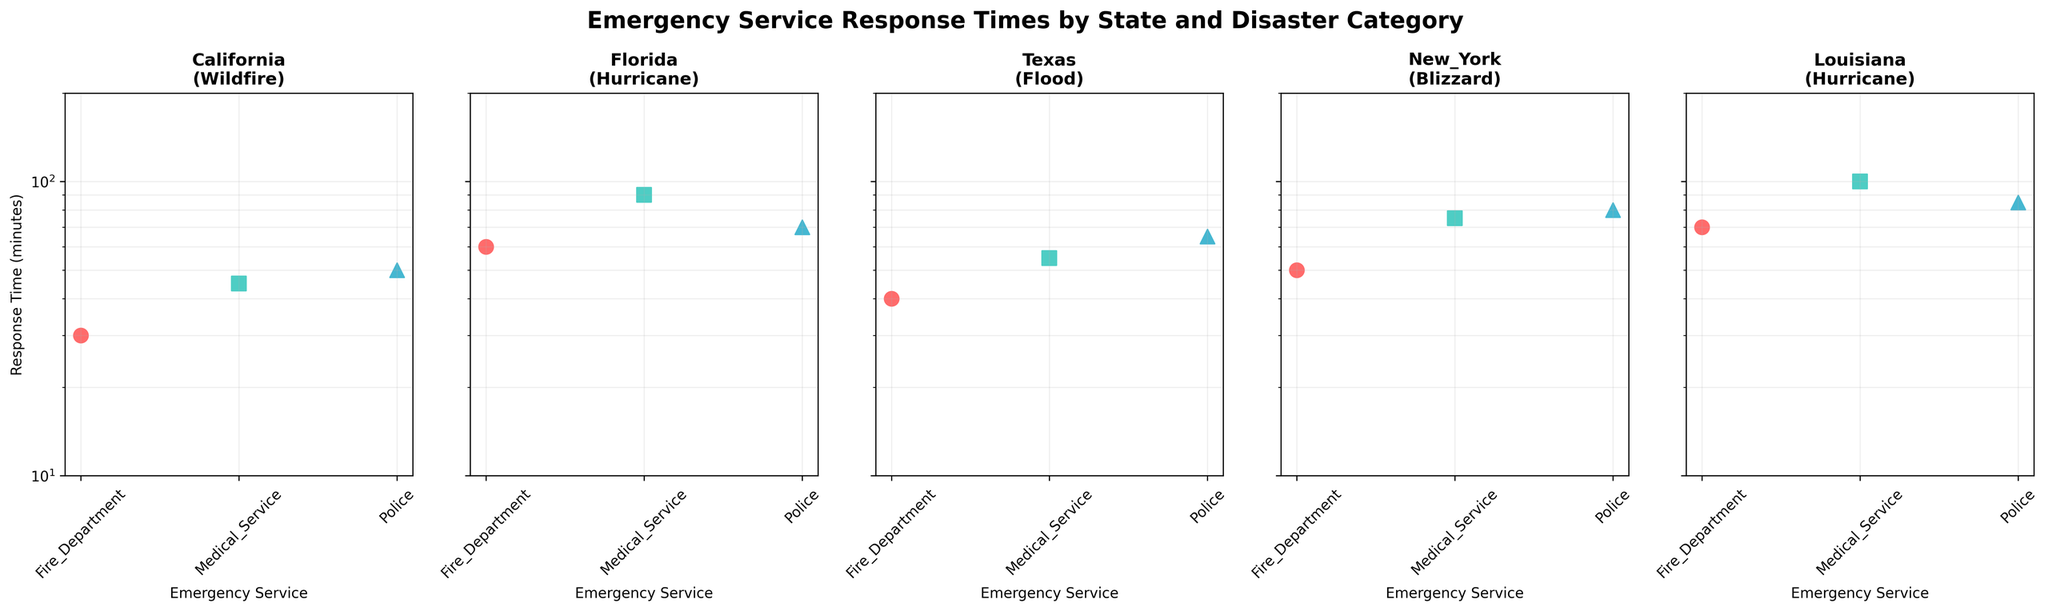What is the title of the figure? The title is located at the top of the figure, in large, bold text, indicating it is about emergency service response times by state and disaster category.
Answer: Emergency Service Response Times by State and Disaster Category Which state has the longest response time for any emergency service? Looking at the y-axes across all states, the highest response time visible is from Louisiana, with Medical Service taking 100 minutes.
Answer: Louisiana Which emergency service has the shortest response time in California? In the subplot for California, Fire Department shows the shortest response time, indicated by markers on the y-axis.
Answer: Fire Department What is the range of response times for Police services across the states? Looking across all subplots for markers associated with Police, the response times range from 50 minutes in California to 85 minutes in Louisiana.
Answer: 50 to 85 minutes Compare the response times of Fire Department and Medical Service in Texas. Which service responds faster? From the Texas subplot, the Fire Department has a response time of 40 minutes, whereas Medical Service has 55 minutes. A comparison shows Fire Department responds faster.
Answer: Fire Department Is there any state where the Fire Department has the longest response time compared to other services? By examining the subplots individually for each state, it can be identified that in Louisiana, Fire Department has a response time of 70 minutes, which is shorter compared to Medical Service (100) and Police (85). Therefore, no state has the longest response time for Fire Department.
Answer: No What is the average response time for emergency services in New York? The response times for New York are 50 (Fire Department), 75 (Medical Service), and 80 (Police). Summing these (50 + 75 + 80) gives 205, and dividing by 3 services provides an average response time of approximately 68.33 minutes.
Answer: 68.33 minutes Which state has the most consistent emergency service response times? Consistency can be assessed by the range between the shortest and longest response times. Texas has a range from 40 minutes (Fire Department) to 65 minutes (Police), making it more consistent compared to other states with wider ranges.
Answer: Texas If you were to add up all the response times for Police service across the states, what would be the total? Summing the response times of Police services from each state: California (50) + Florida (70) + Texas (65) + New York (80) + Louisiana (85) results in 350 minutes.
Answer: 350 minutes Which emergency service category shows the most variation in response times across the states? Looking across all subplots, Medical Service varies significantly from 45 minutes in California to 100 minutes in Louisiana, indicating the most variation.
Answer: Medical Service 